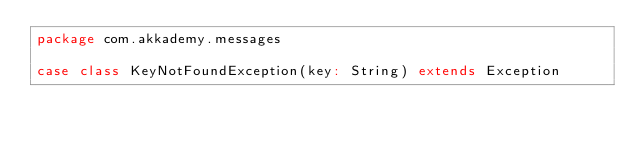Convert code to text. <code><loc_0><loc_0><loc_500><loc_500><_Scala_>package com.akkademy.messages

case class KeyNotFoundException(key: String) extends Exception
</code> 